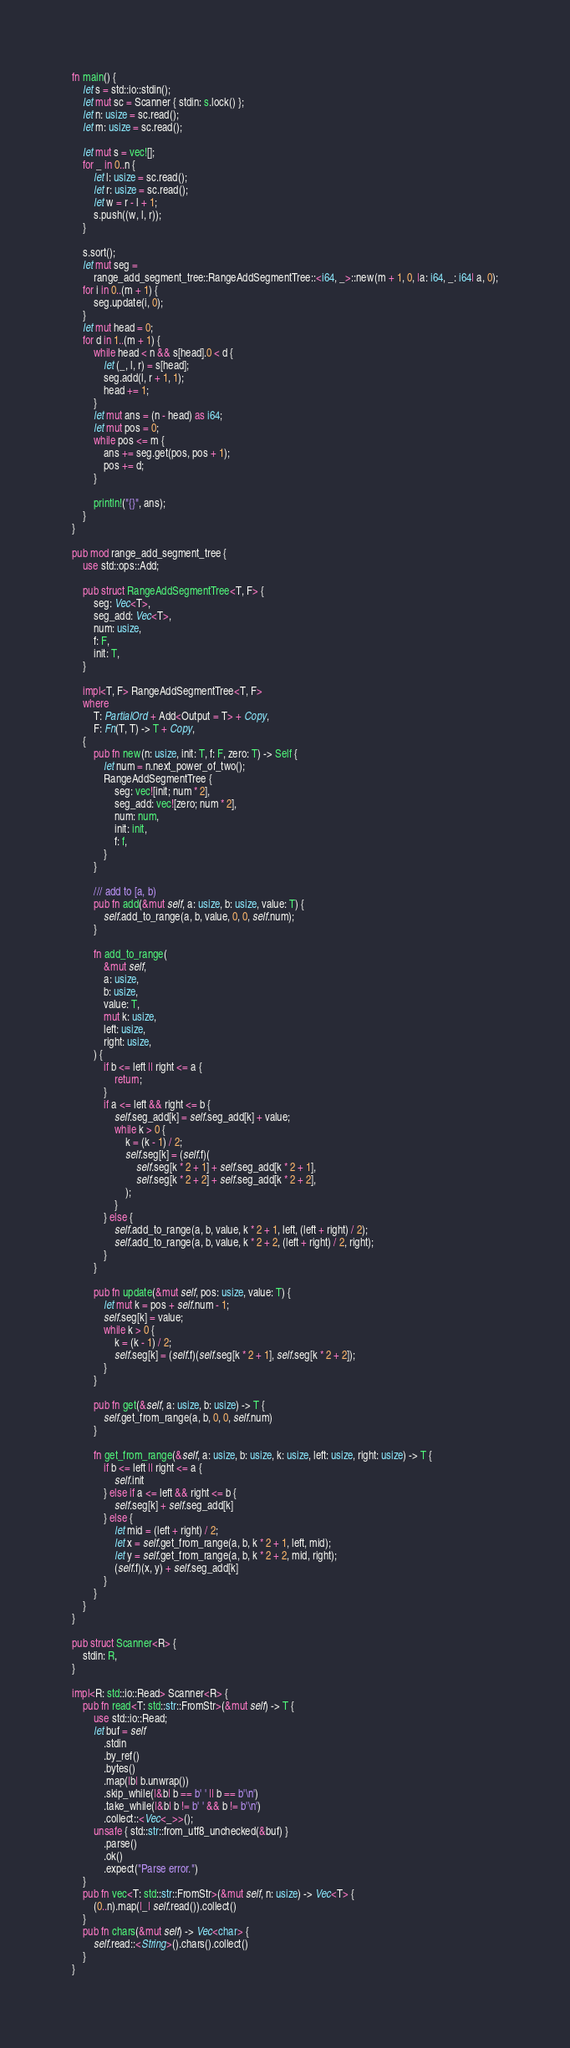<code> <loc_0><loc_0><loc_500><loc_500><_Rust_>fn main() {
    let s = std::io::stdin();
    let mut sc = Scanner { stdin: s.lock() };
    let n: usize = sc.read();
    let m: usize = sc.read();

    let mut s = vec![];
    for _ in 0..n {
        let l: usize = sc.read();
        let r: usize = sc.read();
        let w = r - l + 1;
        s.push((w, l, r));
    }

    s.sort();
    let mut seg =
        range_add_segment_tree::RangeAddSegmentTree::<i64, _>::new(m + 1, 0, |a: i64, _: i64| a, 0);
    for i in 0..(m + 1) {
        seg.update(i, 0);
    }
    let mut head = 0;
    for d in 1..(m + 1) {
        while head < n && s[head].0 < d {
            let (_, l, r) = s[head];
            seg.add(l, r + 1, 1);
            head += 1;
        }
        let mut ans = (n - head) as i64;
        let mut pos = 0;
        while pos <= m {
            ans += seg.get(pos, pos + 1);
            pos += d;
        }

        println!("{}", ans);
    }
}

pub mod range_add_segment_tree {
    use std::ops::Add;

    pub struct RangeAddSegmentTree<T, F> {
        seg: Vec<T>,
        seg_add: Vec<T>,
        num: usize,
        f: F,
        init: T,
    }

    impl<T, F> RangeAddSegmentTree<T, F>
    where
        T: PartialOrd + Add<Output = T> + Copy,
        F: Fn(T, T) -> T + Copy,
    {
        pub fn new(n: usize, init: T, f: F, zero: T) -> Self {
            let num = n.next_power_of_two();
            RangeAddSegmentTree {
                seg: vec![init; num * 2],
                seg_add: vec![zero; num * 2],
                num: num,
                init: init,
                f: f,
            }
        }

        /// add to [a, b)
        pub fn add(&mut self, a: usize, b: usize, value: T) {
            self.add_to_range(a, b, value, 0, 0, self.num);
        }

        fn add_to_range(
            &mut self,
            a: usize,
            b: usize,
            value: T,
            mut k: usize,
            left: usize,
            right: usize,
        ) {
            if b <= left || right <= a {
                return;
            }
            if a <= left && right <= b {
                self.seg_add[k] = self.seg_add[k] + value;
                while k > 0 {
                    k = (k - 1) / 2;
                    self.seg[k] = (self.f)(
                        self.seg[k * 2 + 1] + self.seg_add[k * 2 + 1],
                        self.seg[k * 2 + 2] + self.seg_add[k * 2 + 2],
                    );
                }
            } else {
                self.add_to_range(a, b, value, k * 2 + 1, left, (left + right) / 2);
                self.add_to_range(a, b, value, k * 2 + 2, (left + right) / 2, right);
            }
        }

        pub fn update(&mut self, pos: usize, value: T) {
            let mut k = pos + self.num - 1;
            self.seg[k] = value;
            while k > 0 {
                k = (k - 1) / 2;
                self.seg[k] = (self.f)(self.seg[k * 2 + 1], self.seg[k * 2 + 2]);
            }
        }

        pub fn get(&self, a: usize, b: usize) -> T {
            self.get_from_range(a, b, 0, 0, self.num)
        }

        fn get_from_range(&self, a: usize, b: usize, k: usize, left: usize, right: usize) -> T {
            if b <= left || right <= a {
                self.init
            } else if a <= left && right <= b {
                self.seg[k] + self.seg_add[k]
            } else {
                let mid = (left + right) / 2;
                let x = self.get_from_range(a, b, k * 2 + 1, left, mid);
                let y = self.get_from_range(a, b, k * 2 + 2, mid, right);
                (self.f)(x, y) + self.seg_add[k]
            }
        }
    }
}

pub struct Scanner<R> {
    stdin: R,
}

impl<R: std::io::Read> Scanner<R> {
    pub fn read<T: std::str::FromStr>(&mut self) -> T {
        use std::io::Read;
        let buf = self
            .stdin
            .by_ref()
            .bytes()
            .map(|b| b.unwrap())
            .skip_while(|&b| b == b' ' || b == b'\n')
            .take_while(|&b| b != b' ' && b != b'\n')
            .collect::<Vec<_>>();
        unsafe { std::str::from_utf8_unchecked(&buf) }
            .parse()
            .ok()
            .expect("Parse error.")
    }
    pub fn vec<T: std::str::FromStr>(&mut self, n: usize) -> Vec<T> {
        (0..n).map(|_| self.read()).collect()
    }
    pub fn chars(&mut self) -> Vec<char> {
        self.read::<String>().chars().collect()
    }
}
</code> 